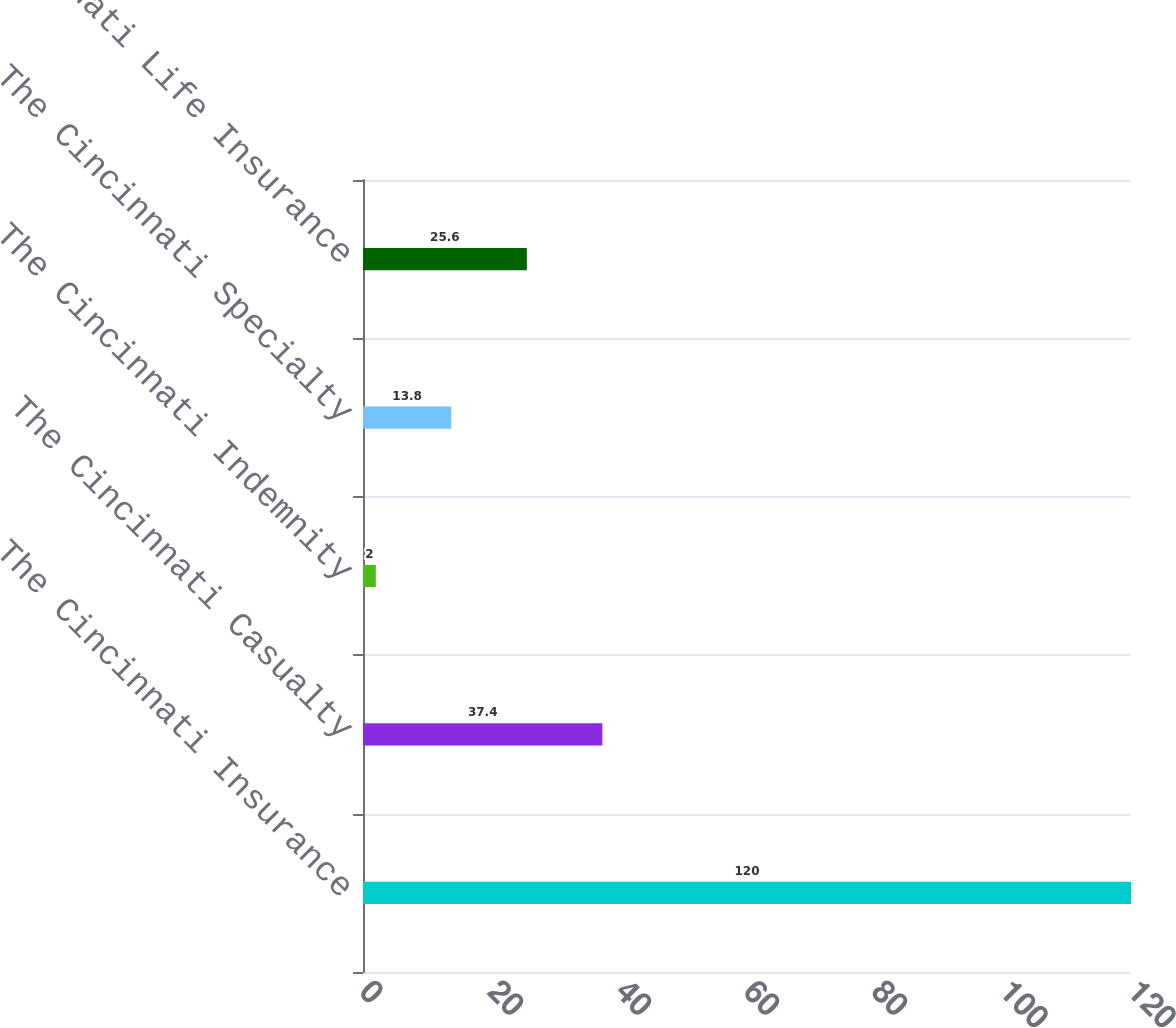<chart> <loc_0><loc_0><loc_500><loc_500><bar_chart><fcel>The Cincinnati Insurance<fcel>The Cincinnati Casualty<fcel>The Cincinnati Indemnity<fcel>The Cincinnati Specialty<fcel>The Cincinnati Life Insurance<nl><fcel>120<fcel>37.4<fcel>2<fcel>13.8<fcel>25.6<nl></chart> 